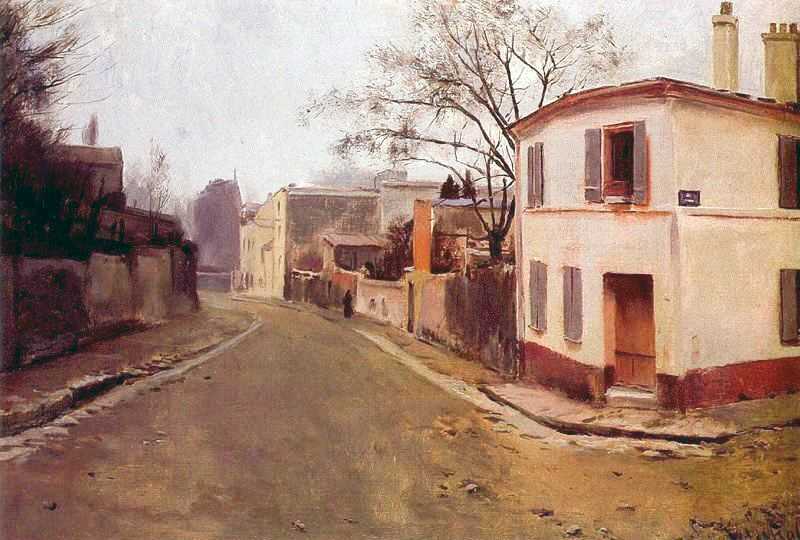If you were to step into this painting, what sounds might you hear? If you were to step into this painting, the sounds you'd hear would be subtle and serene. The gentle rustling of leaves in the breeze would be accompanied by the soft footsteps of a passerby on the cobblestone street. Occasionally, you might hear distant birds chirping or the faint sound of a wooden door creaking open or closed. The quietness of the scene suggests a tranquil environment, free from the noise of modern life, where natural sounds dominate. 